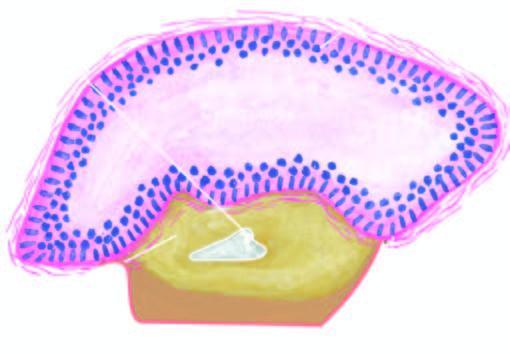s onsumption of tobacco in india also seen in the wall?
Answer the question using a single word or phrase. No 